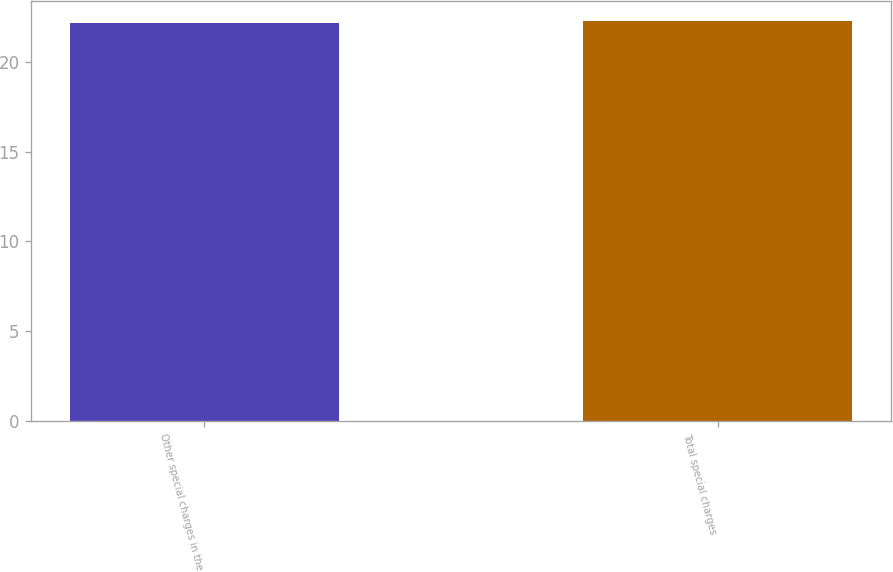Convert chart. <chart><loc_0><loc_0><loc_500><loc_500><bar_chart><fcel>Other special charges in the<fcel>Total special charges<nl><fcel>22.2<fcel>22.3<nl></chart> 